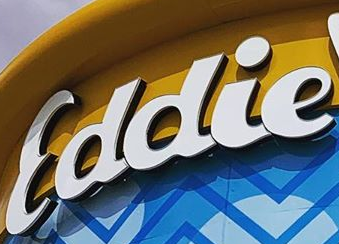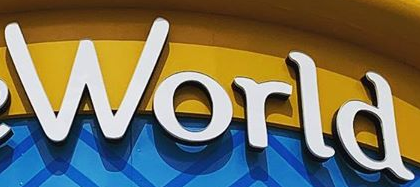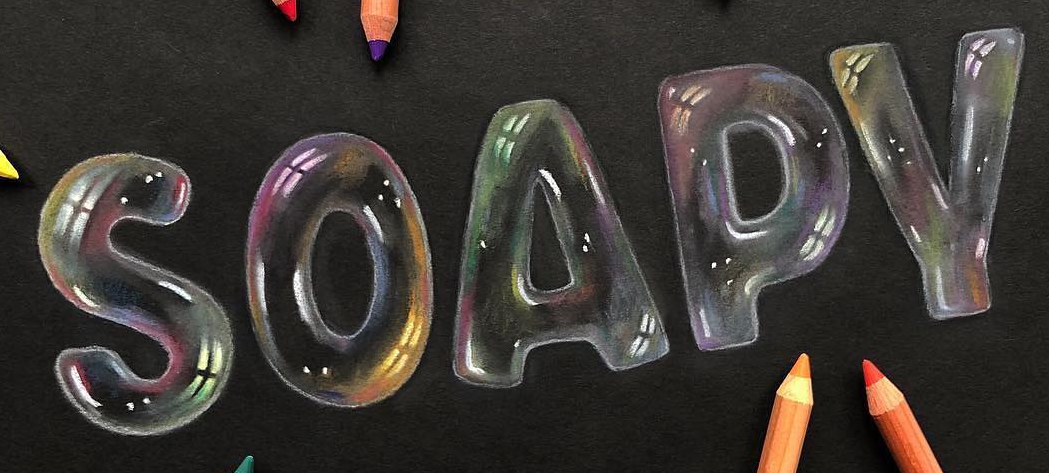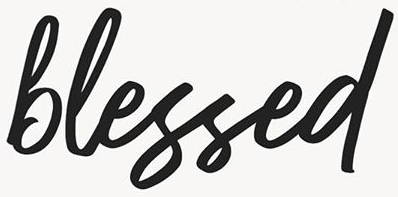What words are shown in these images in order, separated by a semicolon? Eddie; World; SOAPY; blessed 